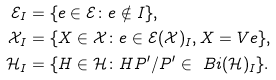<formula> <loc_0><loc_0><loc_500><loc_500>\mathcal { E } _ { I } & = \{ e \in \mathcal { E } \colon e \notin I \} , \\ \mathcal { X } _ { I } & = \{ X \in \mathcal { X } \colon e \in \mathcal { E } ( \mathcal { X } ) _ { I } , X = V e \} , \\ \mathcal { H } _ { I } & = \{ H \in \mathcal { H } \colon H P ^ { \prime } / P ^ { \prime } \in \ B i ( \mathcal { H } ) _ { I } \} .</formula> 